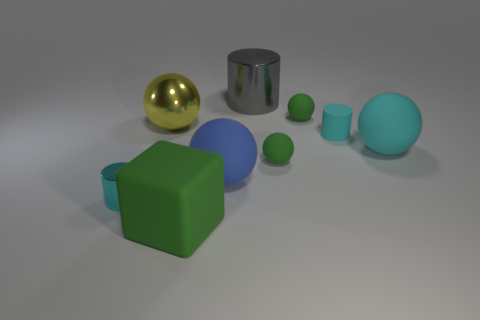Do the small shiny thing and the tiny cylinder that is right of the large cylinder have the same color?
Keep it short and to the point. Yes. What number of other things are there of the same size as the rubber cylinder?
Your answer should be very brief. 3. There is a ball that is the same color as the small metal object; what is its size?
Your answer should be very brief. Large. What number of blocks are big cyan things or small red matte objects?
Offer a very short reply. 0. Do the large metallic object to the left of the blue object and the tiny metallic object have the same shape?
Provide a succinct answer. No. Is the number of big cubes that are to the right of the large green matte thing greater than the number of cyan balls?
Your response must be concise. No. What color is the metallic sphere that is the same size as the green cube?
Your answer should be very brief. Yellow. What number of objects are either tiny green things in front of the yellow shiny ball or big green rubber blocks?
Make the answer very short. 2. The big matte object that is the same color as the rubber cylinder is what shape?
Your answer should be compact. Sphere. There is a large ball behind the tiny cyan cylinder that is on the right side of the large cylinder; what is its material?
Offer a terse response. Metal. 